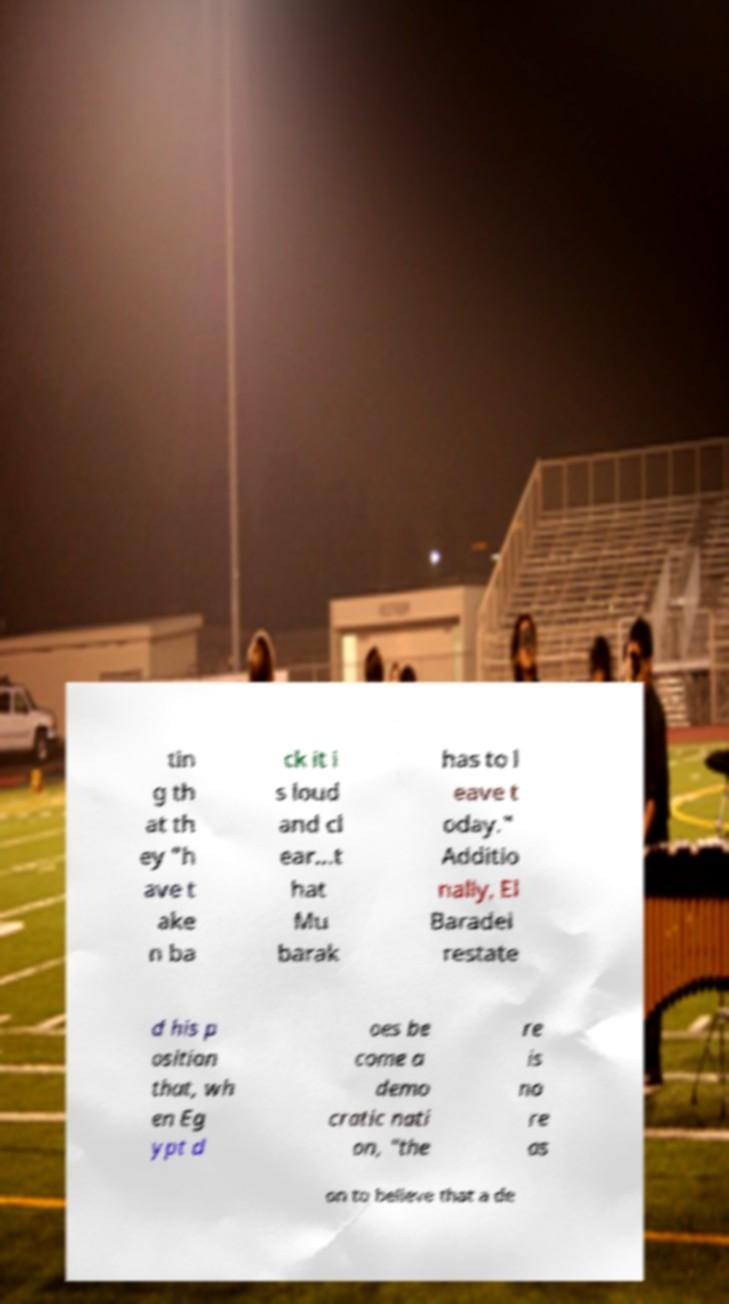What messages or text are displayed in this image? I need them in a readable, typed format. tin g th at th ey "h ave t ake n ba ck it i s loud and cl ear...t hat Mu barak has to l eave t oday." Additio nally, El Baradei restate d his p osition that, wh en Eg ypt d oes be come a demo cratic nati on, "the re is no re as on to believe that a de 